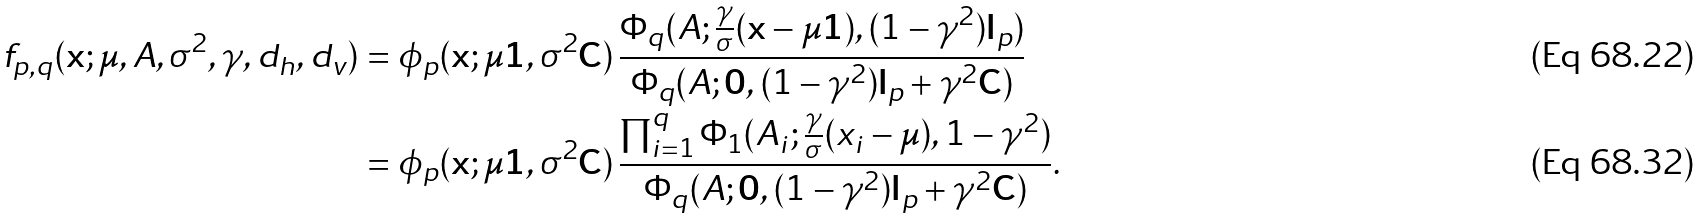Convert formula to latex. <formula><loc_0><loc_0><loc_500><loc_500>f _ { p , q } ( \mathbf x ; \mu , A , \sigma ^ { 2 } , \gamma , d _ { h } , d _ { v } ) & = \phi _ { p } ( \mathbf x ; \mu \mathbf 1 , \sigma ^ { 2 } \mathbf C ) \, \frac { \Phi _ { q } ( A ; \frac { \gamma } { \sigma } ( \mathbf x - \mu \mathbf 1 ) , ( 1 - \gamma ^ { 2 } ) \mathbf I _ { p } ) } { \Phi _ { q } ( A ; \mathbf 0 , ( 1 - \gamma ^ { 2 } ) \mathbf I _ { p } + \gamma ^ { 2 } \mathbf C ) } \\ & = \phi _ { p } ( \mathbf x ; \mu \mathbf 1 , \sigma ^ { 2 } \mathbf C ) \, \frac { \prod _ { i = 1 } ^ { q } \Phi _ { 1 } ( A _ { i } ; \frac { \gamma } { \sigma } ( x _ { i } - \mu ) , 1 - \gamma ^ { 2 } ) } { \Phi _ { q } ( A ; \mathbf 0 , ( 1 - \gamma ^ { 2 } ) \mathbf I _ { p } + \gamma ^ { 2 } \mathbf C ) } .</formula> 